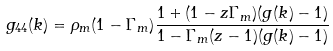<formula> <loc_0><loc_0><loc_500><loc_500>g _ { 4 4 } ( k ) = \rho _ { m } ( 1 - \Gamma _ { m } ) \frac { 1 + ( 1 - z \Gamma _ { m } ) ( g ( k ) - 1 ) } { 1 - \Gamma _ { m } ( z - 1 ) ( g ( k ) - 1 ) }</formula> 